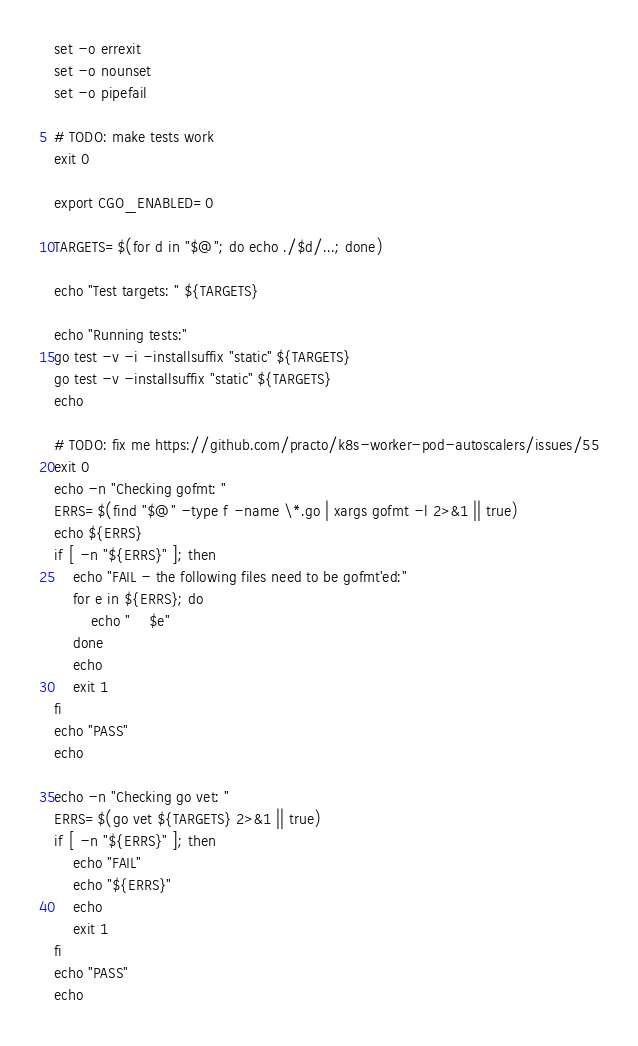Convert code to text. <code><loc_0><loc_0><loc_500><loc_500><_Bash_>set -o errexit
set -o nounset
set -o pipefail

# TODO: make tests work
exit 0

export CGO_ENABLED=0

TARGETS=$(for d in "$@"; do echo ./$d/...; done)

echo "Test targets: " ${TARGETS}

echo "Running tests:"
go test -v -i -installsuffix "static" ${TARGETS}
go test -v -installsuffix "static" ${TARGETS}
echo

# TODO: fix me https://github.com/practo/k8s-worker-pod-autoscalers/issues/55
exit 0
echo -n "Checking gofmt: "
ERRS=$(find "$@" -type f -name \*.go | xargs gofmt -l 2>&1 || true)
echo ${ERRS}
if [ -n "${ERRS}" ]; then
    echo "FAIL - the following files need to be gofmt'ed:"
    for e in ${ERRS}; do
        echo "    $e"
    done
    echo
    exit 1
fi
echo "PASS"
echo

echo -n "Checking go vet: "
ERRS=$(go vet ${TARGETS} 2>&1 || true)
if [ -n "${ERRS}" ]; then
    echo "FAIL"
    echo "${ERRS}"
    echo
    exit 1
fi
echo "PASS"
echo
</code> 